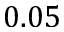<formula> <loc_0><loc_0><loc_500><loc_500>0 . 0 5</formula> 